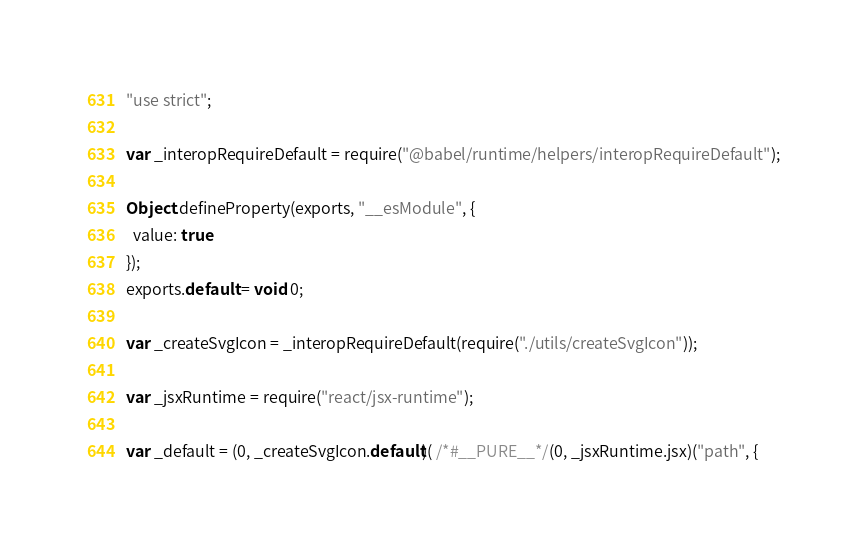Convert code to text. <code><loc_0><loc_0><loc_500><loc_500><_JavaScript_>"use strict";

var _interopRequireDefault = require("@babel/runtime/helpers/interopRequireDefault");

Object.defineProperty(exports, "__esModule", {
  value: true
});
exports.default = void 0;

var _createSvgIcon = _interopRequireDefault(require("./utils/createSvgIcon"));

var _jsxRuntime = require("react/jsx-runtime");

var _default = (0, _createSvgIcon.default)( /*#__PURE__*/(0, _jsxRuntime.jsx)("path", {</code> 